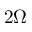<formula> <loc_0><loc_0><loc_500><loc_500>2 \Omega</formula> 